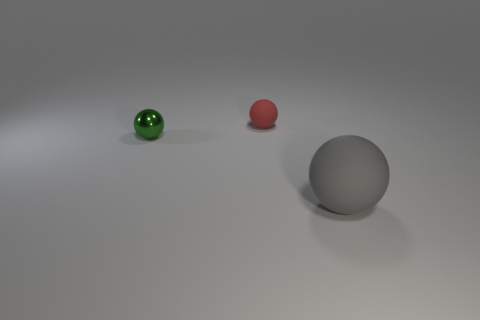Add 3 yellow rubber spheres. How many objects exist? 6 Add 1 large matte balls. How many large matte balls are left? 2 Add 2 small red rubber balls. How many small red rubber balls exist? 3 Subtract 0 cyan balls. How many objects are left? 3 Subtract all big gray rubber balls. Subtract all tiny red objects. How many objects are left? 1 